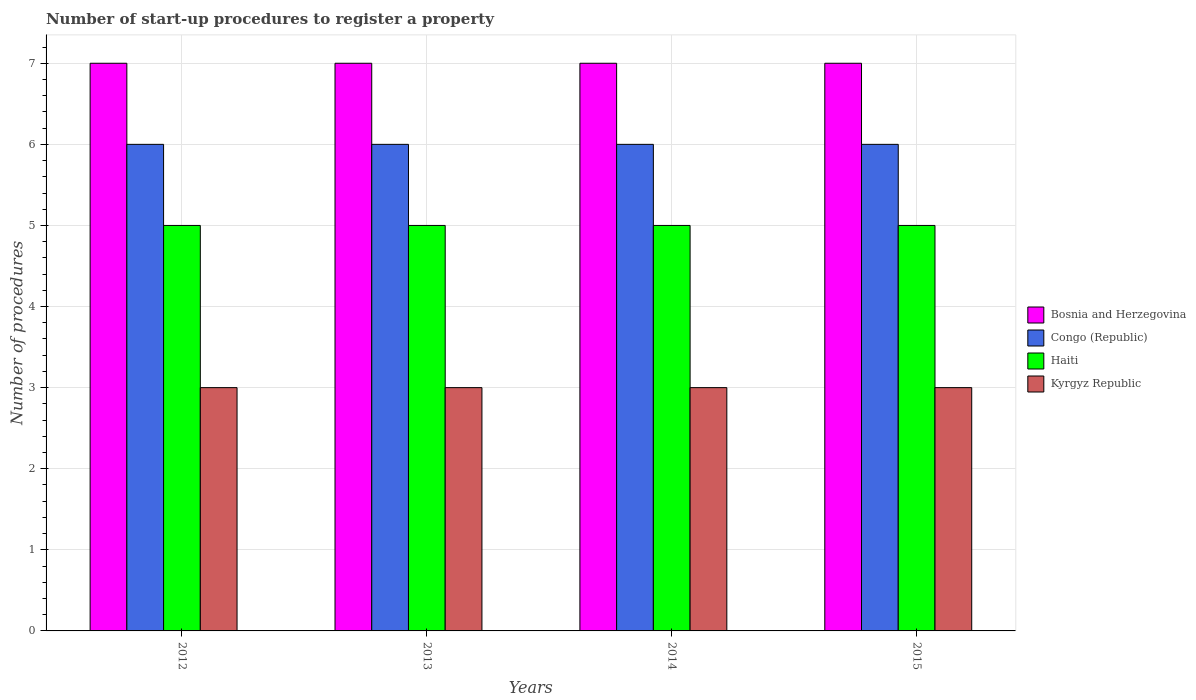How many different coloured bars are there?
Provide a short and direct response. 4. How many groups of bars are there?
Your response must be concise. 4. Are the number of bars per tick equal to the number of legend labels?
Your answer should be compact. Yes. Are the number of bars on each tick of the X-axis equal?
Provide a succinct answer. Yes. How many bars are there on the 3rd tick from the left?
Make the answer very short. 4. What is the label of the 2nd group of bars from the left?
Offer a terse response. 2013. What is the number of procedures required to register a property in Congo (Republic) in 2013?
Ensure brevity in your answer.  6. Across all years, what is the maximum number of procedures required to register a property in Bosnia and Herzegovina?
Offer a terse response. 7. Across all years, what is the minimum number of procedures required to register a property in Kyrgyz Republic?
Provide a short and direct response. 3. What is the total number of procedures required to register a property in Congo (Republic) in the graph?
Provide a succinct answer. 24. What is the difference between the number of procedures required to register a property in Kyrgyz Republic in 2013 and that in 2015?
Provide a short and direct response. 0. What is the difference between the number of procedures required to register a property in Kyrgyz Republic in 2014 and the number of procedures required to register a property in Congo (Republic) in 2013?
Offer a terse response. -3. What is the average number of procedures required to register a property in Bosnia and Herzegovina per year?
Provide a short and direct response. 7. In the year 2014, what is the difference between the number of procedures required to register a property in Haiti and number of procedures required to register a property in Bosnia and Herzegovina?
Your answer should be very brief. -2. Is the number of procedures required to register a property in Kyrgyz Republic in 2012 less than that in 2014?
Offer a very short reply. No. What is the difference between the highest and the second highest number of procedures required to register a property in Congo (Republic)?
Your answer should be compact. 0. In how many years, is the number of procedures required to register a property in Kyrgyz Republic greater than the average number of procedures required to register a property in Kyrgyz Republic taken over all years?
Offer a terse response. 0. Is it the case that in every year, the sum of the number of procedures required to register a property in Congo (Republic) and number of procedures required to register a property in Bosnia and Herzegovina is greater than the sum of number of procedures required to register a property in Kyrgyz Republic and number of procedures required to register a property in Haiti?
Provide a succinct answer. No. What does the 2nd bar from the left in 2015 represents?
Offer a terse response. Congo (Republic). What does the 4th bar from the right in 2015 represents?
Your response must be concise. Bosnia and Herzegovina. How many bars are there?
Keep it short and to the point. 16. How many years are there in the graph?
Give a very brief answer. 4. What is the difference between two consecutive major ticks on the Y-axis?
Offer a very short reply. 1. Does the graph contain any zero values?
Offer a very short reply. No. Where does the legend appear in the graph?
Ensure brevity in your answer.  Center right. What is the title of the graph?
Your answer should be very brief. Number of start-up procedures to register a property. Does "El Salvador" appear as one of the legend labels in the graph?
Give a very brief answer. No. What is the label or title of the X-axis?
Offer a very short reply. Years. What is the label or title of the Y-axis?
Provide a short and direct response. Number of procedures. What is the Number of procedures in Kyrgyz Republic in 2012?
Provide a succinct answer. 3. What is the Number of procedures of Kyrgyz Republic in 2013?
Your response must be concise. 3. What is the Number of procedures in Bosnia and Herzegovina in 2014?
Your answer should be compact. 7. What is the Number of procedures of Haiti in 2014?
Ensure brevity in your answer.  5. What is the Number of procedures of Kyrgyz Republic in 2014?
Offer a terse response. 3. What is the Number of procedures in Congo (Republic) in 2015?
Offer a very short reply. 6. Across all years, what is the maximum Number of procedures in Congo (Republic)?
Provide a short and direct response. 6. Across all years, what is the minimum Number of procedures of Bosnia and Herzegovina?
Give a very brief answer. 7. Across all years, what is the minimum Number of procedures of Congo (Republic)?
Offer a terse response. 6. Across all years, what is the minimum Number of procedures in Haiti?
Offer a terse response. 5. What is the total Number of procedures of Bosnia and Herzegovina in the graph?
Offer a terse response. 28. What is the total Number of procedures in Congo (Republic) in the graph?
Provide a succinct answer. 24. What is the difference between the Number of procedures of Haiti in 2012 and that in 2013?
Your answer should be compact. 0. What is the difference between the Number of procedures in Kyrgyz Republic in 2012 and that in 2013?
Keep it short and to the point. 0. What is the difference between the Number of procedures of Bosnia and Herzegovina in 2012 and that in 2014?
Your answer should be very brief. 0. What is the difference between the Number of procedures in Congo (Republic) in 2012 and that in 2014?
Your answer should be compact. 0. What is the difference between the Number of procedures of Bosnia and Herzegovina in 2012 and that in 2015?
Offer a very short reply. 0. What is the difference between the Number of procedures of Kyrgyz Republic in 2012 and that in 2015?
Ensure brevity in your answer.  0. What is the difference between the Number of procedures in Haiti in 2013 and that in 2014?
Provide a short and direct response. 0. What is the difference between the Number of procedures of Kyrgyz Republic in 2013 and that in 2014?
Offer a very short reply. 0. What is the difference between the Number of procedures of Haiti in 2013 and that in 2015?
Your answer should be very brief. 0. What is the difference between the Number of procedures in Kyrgyz Republic in 2013 and that in 2015?
Offer a terse response. 0. What is the difference between the Number of procedures in Bosnia and Herzegovina in 2014 and that in 2015?
Keep it short and to the point. 0. What is the difference between the Number of procedures in Congo (Republic) in 2014 and that in 2015?
Provide a succinct answer. 0. What is the difference between the Number of procedures of Haiti in 2014 and that in 2015?
Give a very brief answer. 0. What is the difference between the Number of procedures of Kyrgyz Republic in 2014 and that in 2015?
Provide a succinct answer. 0. What is the difference between the Number of procedures in Bosnia and Herzegovina in 2012 and the Number of procedures in Haiti in 2013?
Offer a very short reply. 2. What is the difference between the Number of procedures in Bosnia and Herzegovina in 2012 and the Number of procedures in Kyrgyz Republic in 2013?
Give a very brief answer. 4. What is the difference between the Number of procedures in Bosnia and Herzegovina in 2012 and the Number of procedures in Congo (Republic) in 2014?
Your response must be concise. 1. What is the difference between the Number of procedures in Bosnia and Herzegovina in 2012 and the Number of procedures in Haiti in 2014?
Your response must be concise. 2. What is the difference between the Number of procedures in Congo (Republic) in 2012 and the Number of procedures in Haiti in 2014?
Your response must be concise. 1. What is the difference between the Number of procedures of Haiti in 2012 and the Number of procedures of Kyrgyz Republic in 2014?
Make the answer very short. 2. What is the difference between the Number of procedures of Congo (Republic) in 2012 and the Number of procedures of Haiti in 2015?
Ensure brevity in your answer.  1. What is the difference between the Number of procedures of Congo (Republic) in 2012 and the Number of procedures of Kyrgyz Republic in 2015?
Provide a succinct answer. 3. What is the difference between the Number of procedures in Bosnia and Herzegovina in 2013 and the Number of procedures in Congo (Republic) in 2014?
Give a very brief answer. 1. What is the difference between the Number of procedures in Congo (Republic) in 2013 and the Number of procedures in Haiti in 2014?
Make the answer very short. 1. What is the difference between the Number of procedures in Bosnia and Herzegovina in 2013 and the Number of procedures in Haiti in 2015?
Provide a succinct answer. 2. What is the difference between the Number of procedures of Bosnia and Herzegovina in 2013 and the Number of procedures of Kyrgyz Republic in 2015?
Keep it short and to the point. 4. What is the difference between the Number of procedures in Congo (Republic) in 2013 and the Number of procedures in Haiti in 2015?
Keep it short and to the point. 1. What is the difference between the Number of procedures of Congo (Republic) in 2013 and the Number of procedures of Kyrgyz Republic in 2015?
Offer a very short reply. 3. What is the difference between the Number of procedures of Bosnia and Herzegovina in 2014 and the Number of procedures of Congo (Republic) in 2015?
Your response must be concise. 1. What is the difference between the Number of procedures of Bosnia and Herzegovina in 2014 and the Number of procedures of Kyrgyz Republic in 2015?
Your answer should be very brief. 4. What is the difference between the Number of procedures of Congo (Republic) in 2014 and the Number of procedures of Kyrgyz Republic in 2015?
Offer a terse response. 3. What is the average Number of procedures in Haiti per year?
Your answer should be very brief. 5. What is the average Number of procedures of Kyrgyz Republic per year?
Offer a terse response. 3. In the year 2012, what is the difference between the Number of procedures of Bosnia and Herzegovina and Number of procedures of Kyrgyz Republic?
Your response must be concise. 4. In the year 2012, what is the difference between the Number of procedures in Congo (Republic) and Number of procedures in Kyrgyz Republic?
Offer a terse response. 3. In the year 2012, what is the difference between the Number of procedures in Haiti and Number of procedures in Kyrgyz Republic?
Keep it short and to the point. 2. In the year 2013, what is the difference between the Number of procedures of Bosnia and Herzegovina and Number of procedures of Haiti?
Offer a terse response. 2. In the year 2013, what is the difference between the Number of procedures in Bosnia and Herzegovina and Number of procedures in Kyrgyz Republic?
Provide a short and direct response. 4. In the year 2014, what is the difference between the Number of procedures of Congo (Republic) and Number of procedures of Haiti?
Ensure brevity in your answer.  1. In the year 2014, what is the difference between the Number of procedures of Haiti and Number of procedures of Kyrgyz Republic?
Your response must be concise. 2. In the year 2015, what is the difference between the Number of procedures of Bosnia and Herzegovina and Number of procedures of Haiti?
Make the answer very short. 2. In the year 2015, what is the difference between the Number of procedures in Congo (Republic) and Number of procedures in Kyrgyz Republic?
Keep it short and to the point. 3. What is the ratio of the Number of procedures of Congo (Republic) in 2012 to that in 2013?
Your response must be concise. 1. What is the ratio of the Number of procedures in Haiti in 2012 to that in 2013?
Keep it short and to the point. 1. What is the ratio of the Number of procedures in Kyrgyz Republic in 2012 to that in 2013?
Keep it short and to the point. 1. What is the ratio of the Number of procedures in Congo (Republic) in 2012 to that in 2014?
Give a very brief answer. 1. What is the ratio of the Number of procedures in Haiti in 2012 to that in 2014?
Offer a terse response. 1. What is the ratio of the Number of procedures in Congo (Republic) in 2012 to that in 2015?
Your answer should be compact. 1. What is the ratio of the Number of procedures in Haiti in 2012 to that in 2015?
Provide a succinct answer. 1. What is the ratio of the Number of procedures of Kyrgyz Republic in 2012 to that in 2015?
Your answer should be compact. 1. What is the ratio of the Number of procedures in Congo (Republic) in 2013 to that in 2014?
Give a very brief answer. 1. What is the ratio of the Number of procedures of Kyrgyz Republic in 2013 to that in 2014?
Give a very brief answer. 1. What is the ratio of the Number of procedures of Haiti in 2013 to that in 2015?
Give a very brief answer. 1. What is the ratio of the Number of procedures in Bosnia and Herzegovina in 2014 to that in 2015?
Keep it short and to the point. 1. What is the ratio of the Number of procedures in Congo (Republic) in 2014 to that in 2015?
Give a very brief answer. 1. What is the ratio of the Number of procedures in Haiti in 2014 to that in 2015?
Provide a short and direct response. 1. What is the difference between the highest and the second highest Number of procedures of Bosnia and Herzegovina?
Give a very brief answer. 0. What is the difference between the highest and the second highest Number of procedures in Haiti?
Offer a terse response. 0. What is the difference between the highest and the second highest Number of procedures of Kyrgyz Republic?
Your answer should be very brief. 0. What is the difference between the highest and the lowest Number of procedures in Bosnia and Herzegovina?
Make the answer very short. 0. What is the difference between the highest and the lowest Number of procedures of Kyrgyz Republic?
Provide a short and direct response. 0. 